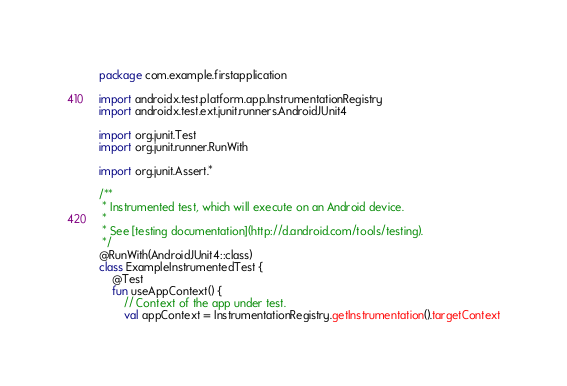Convert code to text. <code><loc_0><loc_0><loc_500><loc_500><_Kotlin_>package com.example.firstapplication

import androidx.test.platform.app.InstrumentationRegistry
import androidx.test.ext.junit.runners.AndroidJUnit4

import org.junit.Test
import org.junit.runner.RunWith

import org.junit.Assert.*

/**
 * Instrumented test, which will execute on an Android device.
 *
 * See [testing documentation](http://d.android.com/tools/testing).
 */
@RunWith(AndroidJUnit4::class)
class ExampleInstrumentedTest {
    @Test
    fun useAppContext() {
        // Context of the app under test.
        val appContext = InstrumentationRegistry.getInstrumentation().targetContext</code> 